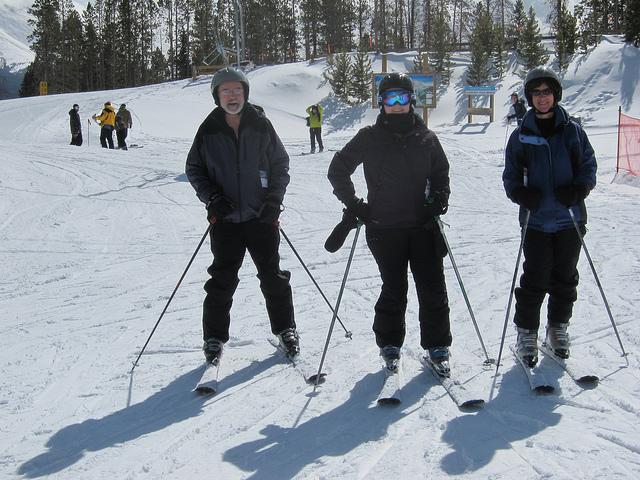Are these athletes snowboarding?
Give a very brief answer. No. Are all the skiers wearing goggles?
Concise answer only. No. Is it snowing?
Be succinct. No. 